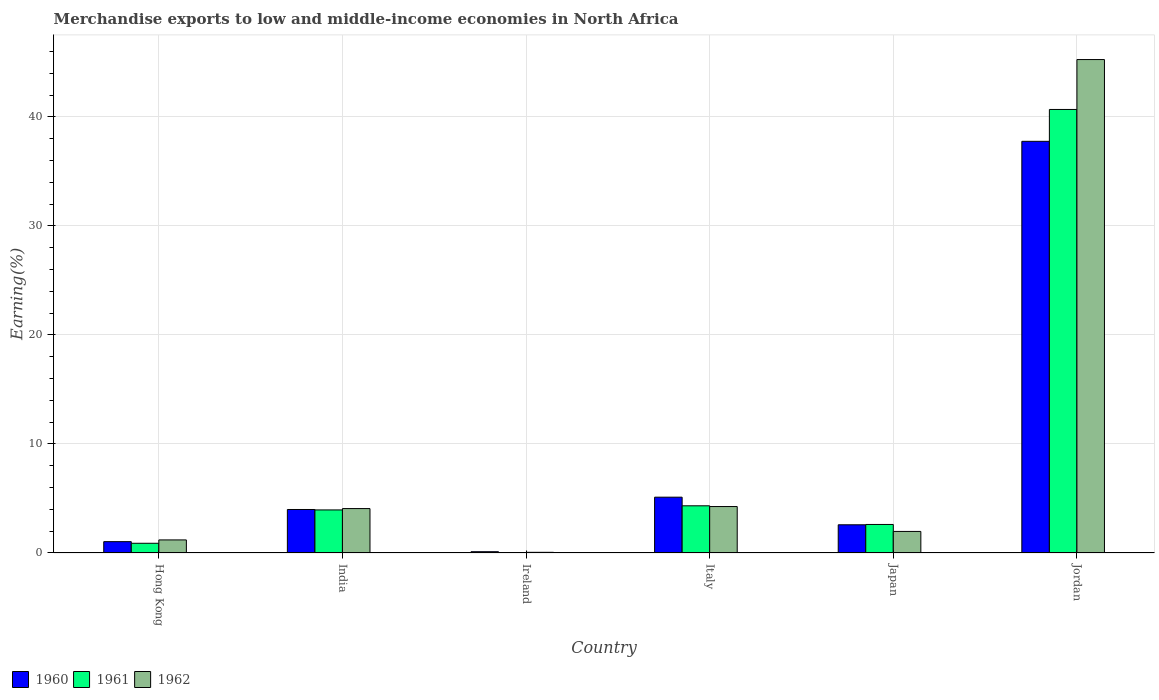How many different coloured bars are there?
Offer a very short reply. 3. How many bars are there on the 5th tick from the left?
Your answer should be compact. 3. What is the label of the 6th group of bars from the left?
Keep it short and to the point. Jordan. What is the percentage of amount earned from merchandise exports in 1961 in Italy?
Your answer should be very brief. 4.33. Across all countries, what is the maximum percentage of amount earned from merchandise exports in 1960?
Provide a short and direct response. 37.76. Across all countries, what is the minimum percentage of amount earned from merchandise exports in 1962?
Your answer should be very brief. 0.06. In which country was the percentage of amount earned from merchandise exports in 1960 maximum?
Provide a short and direct response. Jordan. In which country was the percentage of amount earned from merchandise exports in 1960 minimum?
Offer a terse response. Ireland. What is the total percentage of amount earned from merchandise exports in 1961 in the graph?
Ensure brevity in your answer.  52.5. What is the difference between the percentage of amount earned from merchandise exports in 1960 in Italy and that in Jordan?
Keep it short and to the point. -32.64. What is the difference between the percentage of amount earned from merchandise exports in 1961 in Jordan and the percentage of amount earned from merchandise exports in 1962 in Ireland?
Provide a short and direct response. 40.62. What is the average percentage of amount earned from merchandise exports in 1960 per country?
Offer a terse response. 8.43. What is the difference between the percentage of amount earned from merchandise exports of/in 1960 and percentage of amount earned from merchandise exports of/in 1961 in Japan?
Offer a terse response. -0.03. In how many countries, is the percentage of amount earned from merchandise exports in 1961 greater than 36 %?
Provide a succinct answer. 1. What is the ratio of the percentage of amount earned from merchandise exports in 1962 in India to that in Italy?
Offer a terse response. 0.96. Is the percentage of amount earned from merchandise exports in 1961 in Hong Kong less than that in India?
Ensure brevity in your answer.  Yes. What is the difference between the highest and the second highest percentage of amount earned from merchandise exports in 1960?
Your answer should be very brief. 1.13. What is the difference between the highest and the lowest percentage of amount earned from merchandise exports in 1960?
Give a very brief answer. 37.64. Is the sum of the percentage of amount earned from merchandise exports in 1961 in India and Italy greater than the maximum percentage of amount earned from merchandise exports in 1960 across all countries?
Provide a succinct answer. No. What does the 3rd bar from the left in Italy represents?
Your answer should be compact. 1962. What does the 2nd bar from the right in Italy represents?
Your response must be concise. 1961. Is it the case that in every country, the sum of the percentage of amount earned from merchandise exports in 1962 and percentage of amount earned from merchandise exports in 1961 is greater than the percentage of amount earned from merchandise exports in 1960?
Make the answer very short. No. How many bars are there?
Keep it short and to the point. 18. Where does the legend appear in the graph?
Provide a succinct answer. Bottom left. How are the legend labels stacked?
Give a very brief answer. Horizontal. What is the title of the graph?
Your answer should be very brief. Merchandise exports to low and middle-income economies in North Africa. What is the label or title of the X-axis?
Keep it short and to the point. Country. What is the label or title of the Y-axis?
Offer a terse response. Earning(%). What is the Earning(%) in 1960 in Hong Kong?
Make the answer very short. 1.04. What is the Earning(%) in 1961 in Hong Kong?
Your answer should be very brief. 0.89. What is the Earning(%) in 1962 in Hong Kong?
Offer a very short reply. 1.2. What is the Earning(%) in 1960 in India?
Offer a terse response. 3.99. What is the Earning(%) of 1961 in India?
Offer a terse response. 3.95. What is the Earning(%) of 1962 in India?
Ensure brevity in your answer.  4.07. What is the Earning(%) of 1960 in Ireland?
Give a very brief answer. 0.12. What is the Earning(%) of 1961 in Ireland?
Provide a short and direct response. 0.04. What is the Earning(%) in 1962 in Ireland?
Offer a terse response. 0.06. What is the Earning(%) in 1960 in Italy?
Provide a succinct answer. 5.12. What is the Earning(%) in 1961 in Italy?
Make the answer very short. 4.33. What is the Earning(%) in 1962 in Italy?
Provide a succinct answer. 4.26. What is the Earning(%) of 1960 in Japan?
Your answer should be very brief. 2.59. What is the Earning(%) in 1961 in Japan?
Provide a short and direct response. 2.62. What is the Earning(%) in 1962 in Japan?
Provide a short and direct response. 1.98. What is the Earning(%) of 1960 in Jordan?
Ensure brevity in your answer.  37.76. What is the Earning(%) in 1961 in Jordan?
Keep it short and to the point. 40.68. What is the Earning(%) in 1962 in Jordan?
Offer a very short reply. 45.26. Across all countries, what is the maximum Earning(%) of 1960?
Provide a short and direct response. 37.76. Across all countries, what is the maximum Earning(%) of 1961?
Ensure brevity in your answer.  40.68. Across all countries, what is the maximum Earning(%) in 1962?
Your answer should be very brief. 45.26. Across all countries, what is the minimum Earning(%) in 1960?
Give a very brief answer. 0.12. Across all countries, what is the minimum Earning(%) in 1961?
Your answer should be compact. 0.04. Across all countries, what is the minimum Earning(%) in 1962?
Give a very brief answer. 0.06. What is the total Earning(%) in 1960 in the graph?
Provide a short and direct response. 50.61. What is the total Earning(%) in 1961 in the graph?
Your response must be concise. 52.5. What is the total Earning(%) in 1962 in the graph?
Ensure brevity in your answer.  56.83. What is the difference between the Earning(%) in 1960 in Hong Kong and that in India?
Your answer should be very brief. -2.95. What is the difference between the Earning(%) in 1961 in Hong Kong and that in India?
Provide a succinct answer. -3.06. What is the difference between the Earning(%) in 1962 in Hong Kong and that in India?
Provide a succinct answer. -2.87. What is the difference between the Earning(%) in 1960 in Hong Kong and that in Ireland?
Offer a very short reply. 0.92. What is the difference between the Earning(%) in 1961 in Hong Kong and that in Ireland?
Keep it short and to the point. 0.85. What is the difference between the Earning(%) in 1962 in Hong Kong and that in Ireland?
Give a very brief answer. 1.14. What is the difference between the Earning(%) of 1960 in Hong Kong and that in Italy?
Provide a succinct answer. -4.08. What is the difference between the Earning(%) in 1961 in Hong Kong and that in Italy?
Make the answer very short. -3.44. What is the difference between the Earning(%) of 1962 in Hong Kong and that in Italy?
Your response must be concise. -3.06. What is the difference between the Earning(%) of 1960 in Hong Kong and that in Japan?
Provide a short and direct response. -1.55. What is the difference between the Earning(%) in 1961 in Hong Kong and that in Japan?
Keep it short and to the point. -1.73. What is the difference between the Earning(%) in 1962 in Hong Kong and that in Japan?
Offer a very short reply. -0.78. What is the difference between the Earning(%) in 1960 in Hong Kong and that in Jordan?
Your response must be concise. -36.72. What is the difference between the Earning(%) of 1961 in Hong Kong and that in Jordan?
Offer a terse response. -39.79. What is the difference between the Earning(%) of 1962 in Hong Kong and that in Jordan?
Offer a terse response. -44.06. What is the difference between the Earning(%) of 1960 in India and that in Ireland?
Keep it short and to the point. 3.87. What is the difference between the Earning(%) in 1961 in India and that in Ireland?
Ensure brevity in your answer.  3.91. What is the difference between the Earning(%) of 1962 in India and that in Ireland?
Provide a short and direct response. 4.01. What is the difference between the Earning(%) in 1960 in India and that in Italy?
Keep it short and to the point. -1.13. What is the difference between the Earning(%) of 1961 in India and that in Italy?
Keep it short and to the point. -0.38. What is the difference between the Earning(%) of 1962 in India and that in Italy?
Your response must be concise. -0.19. What is the difference between the Earning(%) of 1960 in India and that in Japan?
Ensure brevity in your answer.  1.4. What is the difference between the Earning(%) in 1961 in India and that in Japan?
Give a very brief answer. 1.33. What is the difference between the Earning(%) in 1962 in India and that in Japan?
Give a very brief answer. 2.1. What is the difference between the Earning(%) in 1960 in India and that in Jordan?
Give a very brief answer. -33.77. What is the difference between the Earning(%) in 1961 in India and that in Jordan?
Offer a terse response. -36.73. What is the difference between the Earning(%) of 1962 in India and that in Jordan?
Give a very brief answer. -41.18. What is the difference between the Earning(%) in 1960 in Ireland and that in Italy?
Offer a very short reply. -5. What is the difference between the Earning(%) of 1961 in Ireland and that in Italy?
Your answer should be compact. -4.29. What is the difference between the Earning(%) of 1962 in Ireland and that in Italy?
Your response must be concise. -4.2. What is the difference between the Earning(%) of 1960 in Ireland and that in Japan?
Give a very brief answer. -2.47. What is the difference between the Earning(%) of 1961 in Ireland and that in Japan?
Your answer should be compact. -2.58. What is the difference between the Earning(%) in 1962 in Ireland and that in Japan?
Make the answer very short. -1.91. What is the difference between the Earning(%) of 1960 in Ireland and that in Jordan?
Offer a very short reply. -37.64. What is the difference between the Earning(%) of 1961 in Ireland and that in Jordan?
Provide a succinct answer. -40.64. What is the difference between the Earning(%) in 1962 in Ireland and that in Jordan?
Offer a very short reply. -45.19. What is the difference between the Earning(%) of 1960 in Italy and that in Japan?
Provide a short and direct response. 2.53. What is the difference between the Earning(%) in 1961 in Italy and that in Japan?
Keep it short and to the point. 1.71. What is the difference between the Earning(%) in 1962 in Italy and that in Japan?
Provide a short and direct response. 2.28. What is the difference between the Earning(%) of 1960 in Italy and that in Jordan?
Ensure brevity in your answer.  -32.64. What is the difference between the Earning(%) in 1961 in Italy and that in Jordan?
Provide a short and direct response. -36.35. What is the difference between the Earning(%) of 1962 in Italy and that in Jordan?
Your response must be concise. -41. What is the difference between the Earning(%) of 1960 in Japan and that in Jordan?
Your response must be concise. -35.17. What is the difference between the Earning(%) of 1961 in Japan and that in Jordan?
Your answer should be very brief. -38.06. What is the difference between the Earning(%) in 1962 in Japan and that in Jordan?
Your answer should be compact. -43.28. What is the difference between the Earning(%) of 1960 in Hong Kong and the Earning(%) of 1961 in India?
Provide a succinct answer. -2.91. What is the difference between the Earning(%) of 1960 in Hong Kong and the Earning(%) of 1962 in India?
Your answer should be very brief. -3.03. What is the difference between the Earning(%) in 1961 in Hong Kong and the Earning(%) in 1962 in India?
Your answer should be compact. -3.18. What is the difference between the Earning(%) in 1960 in Hong Kong and the Earning(%) in 1961 in Ireland?
Your response must be concise. 1. What is the difference between the Earning(%) in 1960 in Hong Kong and the Earning(%) in 1962 in Ireland?
Make the answer very short. 0.98. What is the difference between the Earning(%) in 1961 in Hong Kong and the Earning(%) in 1962 in Ireland?
Ensure brevity in your answer.  0.83. What is the difference between the Earning(%) of 1960 in Hong Kong and the Earning(%) of 1961 in Italy?
Provide a short and direct response. -3.29. What is the difference between the Earning(%) of 1960 in Hong Kong and the Earning(%) of 1962 in Italy?
Offer a very short reply. -3.22. What is the difference between the Earning(%) of 1961 in Hong Kong and the Earning(%) of 1962 in Italy?
Offer a terse response. -3.37. What is the difference between the Earning(%) of 1960 in Hong Kong and the Earning(%) of 1961 in Japan?
Make the answer very short. -1.58. What is the difference between the Earning(%) of 1960 in Hong Kong and the Earning(%) of 1962 in Japan?
Your answer should be very brief. -0.94. What is the difference between the Earning(%) in 1961 in Hong Kong and the Earning(%) in 1962 in Japan?
Your answer should be very brief. -1.09. What is the difference between the Earning(%) in 1960 in Hong Kong and the Earning(%) in 1961 in Jordan?
Keep it short and to the point. -39.64. What is the difference between the Earning(%) in 1960 in Hong Kong and the Earning(%) in 1962 in Jordan?
Provide a short and direct response. -44.22. What is the difference between the Earning(%) of 1961 in Hong Kong and the Earning(%) of 1962 in Jordan?
Give a very brief answer. -44.36. What is the difference between the Earning(%) of 1960 in India and the Earning(%) of 1961 in Ireland?
Your answer should be very brief. 3.95. What is the difference between the Earning(%) in 1960 in India and the Earning(%) in 1962 in Ireland?
Make the answer very short. 3.93. What is the difference between the Earning(%) of 1961 in India and the Earning(%) of 1962 in Ireland?
Offer a very short reply. 3.89. What is the difference between the Earning(%) in 1960 in India and the Earning(%) in 1961 in Italy?
Your answer should be compact. -0.34. What is the difference between the Earning(%) of 1960 in India and the Earning(%) of 1962 in Italy?
Your answer should be compact. -0.27. What is the difference between the Earning(%) in 1961 in India and the Earning(%) in 1962 in Italy?
Your answer should be very brief. -0.31. What is the difference between the Earning(%) in 1960 in India and the Earning(%) in 1961 in Japan?
Ensure brevity in your answer.  1.37. What is the difference between the Earning(%) of 1960 in India and the Earning(%) of 1962 in Japan?
Your response must be concise. 2.01. What is the difference between the Earning(%) in 1961 in India and the Earning(%) in 1962 in Japan?
Make the answer very short. 1.97. What is the difference between the Earning(%) of 1960 in India and the Earning(%) of 1961 in Jordan?
Your response must be concise. -36.69. What is the difference between the Earning(%) in 1960 in India and the Earning(%) in 1962 in Jordan?
Offer a very short reply. -41.27. What is the difference between the Earning(%) of 1961 in India and the Earning(%) of 1962 in Jordan?
Provide a short and direct response. -41.31. What is the difference between the Earning(%) of 1960 in Ireland and the Earning(%) of 1961 in Italy?
Provide a short and direct response. -4.21. What is the difference between the Earning(%) of 1960 in Ireland and the Earning(%) of 1962 in Italy?
Offer a terse response. -4.14. What is the difference between the Earning(%) of 1961 in Ireland and the Earning(%) of 1962 in Italy?
Give a very brief answer. -4.22. What is the difference between the Earning(%) in 1960 in Ireland and the Earning(%) in 1961 in Japan?
Keep it short and to the point. -2.5. What is the difference between the Earning(%) in 1960 in Ireland and the Earning(%) in 1962 in Japan?
Give a very brief answer. -1.86. What is the difference between the Earning(%) of 1961 in Ireland and the Earning(%) of 1962 in Japan?
Your response must be concise. -1.94. What is the difference between the Earning(%) of 1960 in Ireland and the Earning(%) of 1961 in Jordan?
Offer a terse response. -40.56. What is the difference between the Earning(%) of 1960 in Ireland and the Earning(%) of 1962 in Jordan?
Offer a terse response. -45.14. What is the difference between the Earning(%) of 1961 in Ireland and the Earning(%) of 1962 in Jordan?
Keep it short and to the point. -45.22. What is the difference between the Earning(%) of 1960 in Italy and the Earning(%) of 1961 in Japan?
Provide a succinct answer. 2.5. What is the difference between the Earning(%) in 1960 in Italy and the Earning(%) in 1962 in Japan?
Your answer should be very brief. 3.14. What is the difference between the Earning(%) in 1961 in Italy and the Earning(%) in 1962 in Japan?
Provide a short and direct response. 2.35. What is the difference between the Earning(%) in 1960 in Italy and the Earning(%) in 1961 in Jordan?
Keep it short and to the point. -35.56. What is the difference between the Earning(%) of 1960 in Italy and the Earning(%) of 1962 in Jordan?
Provide a succinct answer. -40.14. What is the difference between the Earning(%) in 1961 in Italy and the Earning(%) in 1962 in Jordan?
Ensure brevity in your answer.  -40.93. What is the difference between the Earning(%) in 1960 in Japan and the Earning(%) in 1961 in Jordan?
Give a very brief answer. -38.09. What is the difference between the Earning(%) in 1960 in Japan and the Earning(%) in 1962 in Jordan?
Provide a short and direct response. -42.67. What is the difference between the Earning(%) in 1961 in Japan and the Earning(%) in 1962 in Jordan?
Your response must be concise. -42.64. What is the average Earning(%) of 1960 per country?
Keep it short and to the point. 8.43. What is the average Earning(%) in 1961 per country?
Make the answer very short. 8.75. What is the average Earning(%) of 1962 per country?
Your response must be concise. 9.47. What is the difference between the Earning(%) of 1960 and Earning(%) of 1961 in Hong Kong?
Offer a very short reply. 0.15. What is the difference between the Earning(%) in 1960 and Earning(%) in 1962 in Hong Kong?
Your response must be concise. -0.16. What is the difference between the Earning(%) of 1961 and Earning(%) of 1962 in Hong Kong?
Give a very brief answer. -0.31. What is the difference between the Earning(%) in 1960 and Earning(%) in 1961 in India?
Ensure brevity in your answer.  0.04. What is the difference between the Earning(%) of 1960 and Earning(%) of 1962 in India?
Keep it short and to the point. -0.08. What is the difference between the Earning(%) of 1961 and Earning(%) of 1962 in India?
Provide a succinct answer. -0.12. What is the difference between the Earning(%) in 1960 and Earning(%) in 1961 in Ireland?
Offer a very short reply. 0.08. What is the difference between the Earning(%) in 1960 and Earning(%) in 1962 in Ireland?
Ensure brevity in your answer.  0.06. What is the difference between the Earning(%) of 1961 and Earning(%) of 1962 in Ireland?
Your answer should be compact. -0.02. What is the difference between the Earning(%) in 1960 and Earning(%) in 1961 in Italy?
Ensure brevity in your answer.  0.79. What is the difference between the Earning(%) in 1960 and Earning(%) in 1962 in Italy?
Ensure brevity in your answer.  0.86. What is the difference between the Earning(%) in 1961 and Earning(%) in 1962 in Italy?
Provide a short and direct response. 0.07. What is the difference between the Earning(%) of 1960 and Earning(%) of 1961 in Japan?
Offer a very short reply. -0.03. What is the difference between the Earning(%) in 1960 and Earning(%) in 1962 in Japan?
Offer a terse response. 0.61. What is the difference between the Earning(%) of 1961 and Earning(%) of 1962 in Japan?
Provide a succinct answer. 0.64. What is the difference between the Earning(%) in 1960 and Earning(%) in 1961 in Jordan?
Your answer should be very brief. -2.92. What is the difference between the Earning(%) of 1960 and Earning(%) of 1962 in Jordan?
Provide a succinct answer. -7.5. What is the difference between the Earning(%) in 1961 and Earning(%) in 1962 in Jordan?
Your response must be concise. -4.58. What is the ratio of the Earning(%) in 1960 in Hong Kong to that in India?
Provide a short and direct response. 0.26. What is the ratio of the Earning(%) of 1961 in Hong Kong to that in India?
Offer a terse response. 0.23. What is the ratio of the Earning(%) of 1962 in Hong Kong to that in India?
Your answer should be compact. 0.29. What is the ratio of the Earning(%) in 1960 in Hong Kong to that in Ireland?
Offer a very short reply. 8.84. What is the ratio of the Earning(%) in 1961 in Hong Kong to that in Ireland?
Your answer should be very brief. 22.46. What is the ratio of the Earning(%) in 1962 in Hong Kong to that in Ireland?
Provide a succinct answer. 19.45. What is the ratio of the Earning(%) in 1960 in Hong Kong to that in Italy?
Ensure brevity in your answer.  0.2. What is the ratio of the Earning(%) of 1961 in Hong Kong to that in Italy?
Provide a succinct answer. 0.21. What is the ratio of the Earning(%) of 1962 in Hong Kong to that in Italy?
Offer a very short reply. 0.28. What is the ratio of the Earning(%) in 1960 in Hong Kong to that in Japan?
Your response must be concise. 0.4. What is the ratio of the Earning(%) of 1961 in Hong Kong to that in Japan?
Make the answer very short. 0.34. What is the ratio of the Earning(%) of 1962 in Hong Kong to that in Japan?
Give a very brief answer. 0.61. What is the ratio of the Earning(%) in 1960 in Hong Kong to that in Jordan?
Make the answer very short. 0.03. What is the ratio of the Earning(%) of 1961 in Hong Kong to that in Jordan?
Offer a very short reply. 0.02. What is the ratio of the Earning(%) in 1962 in Hong Kong to that in Jordan?
Your response must be concise. 0.03. What is the ratio of the Earning(%) of 1960 in India to that in Ireland?
Ensure brevity in your answer.  33.93. What is the ratio of the Earning(%) of 1961 in India to that in Ireland?
Provide a short and direct response. 99.57. What is the ratio of the Earning(%) in 1962 in India to that in Ireland?
Provide a succinct answer. 66.07. What is the ratio of the Earning(%) of 1960 in India to that in Italy?
Your response must be concise. 0.78. What is the ratio of the Earning(%) of 1961 in India to that in Italy?
Your answer should be very brief. 0.91. What is the ratio of the Earning(%) of 1962 in India to that in Italy?
Provide a short and direct response. 0.96. What is the ratio of the Earning(%) of 1960 in India to that in Japan?
Your answer should be very brief. 1.54. What is the ratio of the Earning(%) of 1961 in India to that in Japan?
Your response must be concise. 1.51. What is the ratio of the Earning(%) in 1962 in India to that in Japan?
Provide a succinct answer. 2.06. What is the ratio of the Earning(%) of 1960 in India to that in Jordan?
Offer a very short reply. 0.11. What is the ratio of the Earning(%) of 1961 in India to that in Jordan?
Your answer should be very brief. 0.1. What is the ratio of the Earning(%) in 1962 in India to that in Jordan?
Give a very brief answer. 0.09. What is the ratio of the Earning(%) in 1960 in Ireland to that in Italy?
Offer a terse response. 0.02. What is the ratio of the Earning(%) in 1961 in Ireland to that in Italy?
Provide a succinct answer. 0.01. What is the ratio of the Earning(%) in 1962 in Ireland to that in Italy?
Keep it short and to the point. 0.01. What is the ratio of the Earning(%) of 1960 in Ireland to that in Japan?
Your answer should be very brief. 0.05. What is the ratio of the Earning(%) of 1961 in Ireland to that in Japan?
Keep it short and to the point. 0.02. What is the ratio of the Earning(%) in 1962 in Ireland to that in Japan?
Provide a short and direct response. 0.03. What is the ratio of the Earning(%) of 1960 in Ireland to that in Jordan?
Your answer should be very brief. 0. What is the ratio of the Earning(%) in 1962 in Ireland to that in Jordan?
Provide a short and direct response. 0. What is the ratio of the Earning(%) in 1960 in Italy to that in Japan?
Provide a short and direct response. 1.98. What is the ratio of the Earning(%) in 1961 in Italy to that in Japan?
Make the answer very short. 1.65. What is the ratio of the Earning(%) in 1962 in Italy to that in Japan?
Offer a terse response. 2.16. What is the ratio of the Earning(%) of 1960 in Italy to that in Jordan?
Keep it short and to the point. 0.14. What is the ratio of the Earning(%) in 1961 in Italy to that in Jordan?
Make the answer very short. 0.11. What is the ratio of the Earning(%) of 1962 in Italy to that in Jordan?
Give a very brief answer. 0.09. What is the ratio of the Earning(%) in 1960 in Japan to that in Jordan?
Give a very brief answer. 0.07. What is the ratio of the Earning(%) in 1961 in Japan to that in Jordan?
Your answer should be compact. 0.06. What is the ratio of the Earning(%) in 1962 in Japan to that in Jordan?
Provide a succinct answer. 0.04. What is the difference between the highest and the second highest Earning(%) in 1960?
Keep it short and to the point. 32.64. What is the difference between the highest and the second highest Earning(%) in 1961?
Offer a terse response. 36.35. What is the difference between the highest and the second highest Earning(%) in 1962?
Ensure brevity in your answer.  41. What is the difference between the highest and the lowest Earning(%) in 1960?
Make the answer very short. 37.64. What is the difference between the highest and the lowest Earning(%) of 1961?
Keep it short and to the point. 40.64. What is the difference between the highest and the lowest Earning(%) of 1962?
Ensure brevity in your answer.  45.19. 